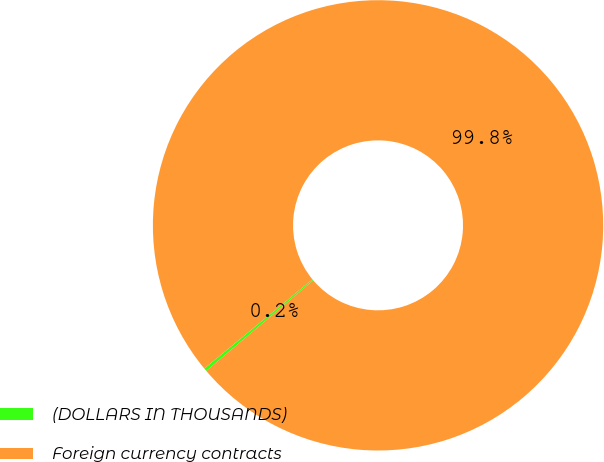<chart> <loc_0><loc_0><loc_500><loc_500><pie_chart><fcel>(DOLLARS IN THOUSANDS)<fcel>Foreign currency contracts<nl><fcel>0.22%<fcel>99.78%<nl></chart> 